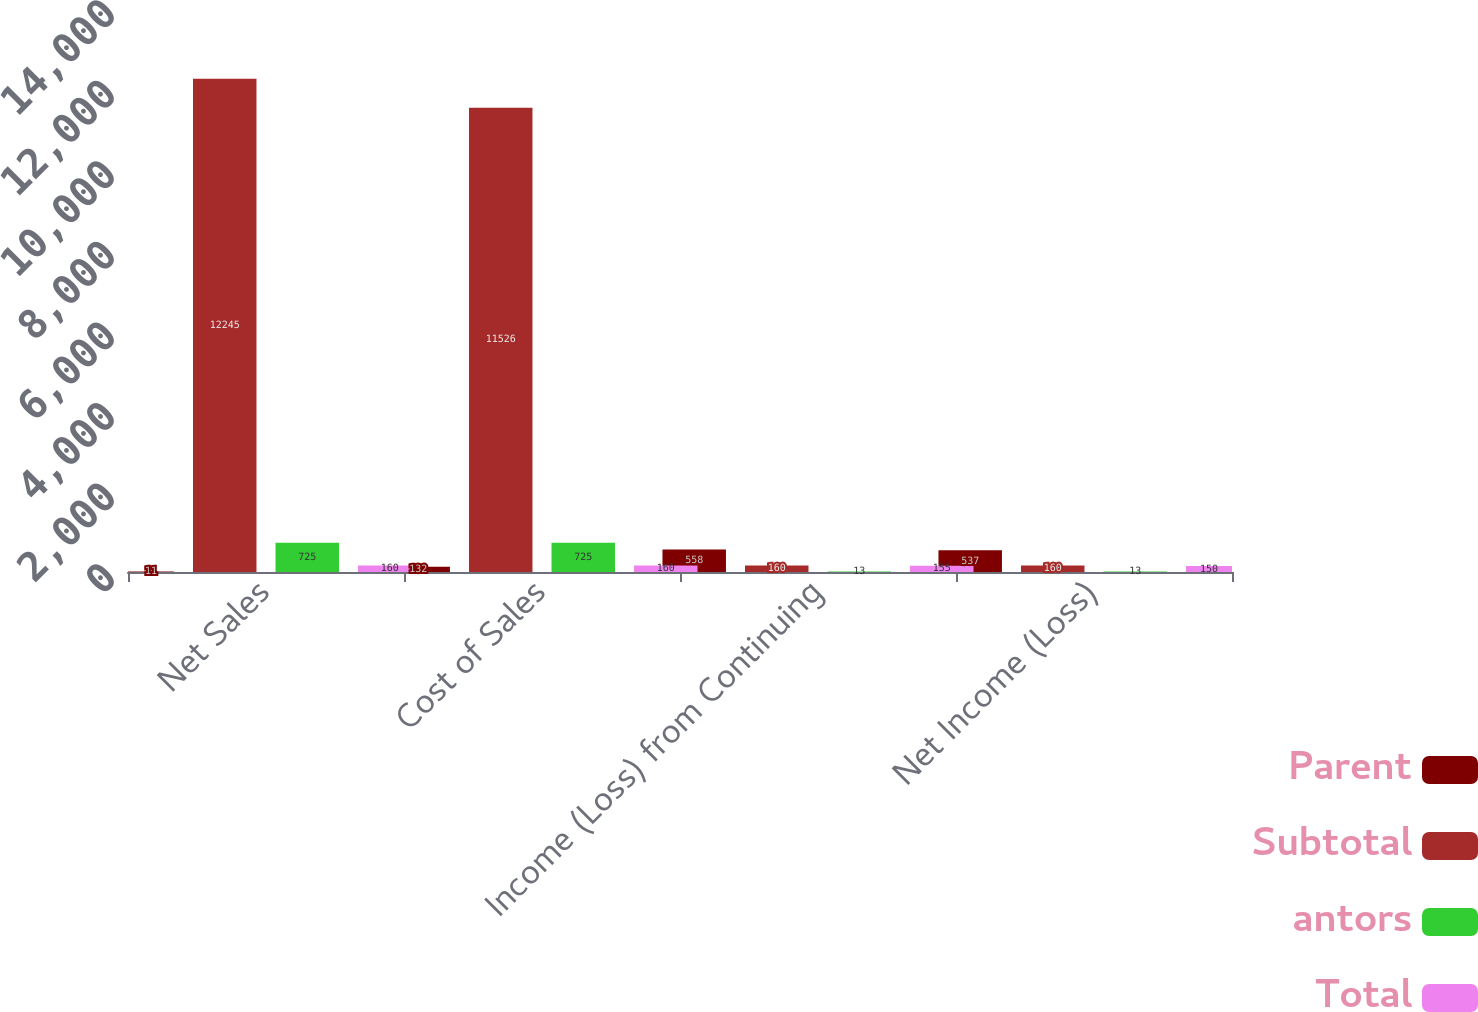Convert chart to OTSL. <chart><loc_0><loc_0><loc_500><loc_500><stacked_bar_chart><ecel><fcel>Net Sales<fcel>Cost of Sales<fcel>Income (Loss) from Continuing<fcel>Net Income (Loss)<nl><fcel>Parent<fcel>11<fcel>132<fcel>558<fcel>537<nl><fcel>Subtotal<fcel>12245<fcel>11526<fcel>160<fcel>160<nl><fcel>antors<fcel>725<fcel>725<fcel>13<fcel>13<nl><fcel>Total<fcel>160<fcel>160<fcel>155<fcel>150<nl></chart> 